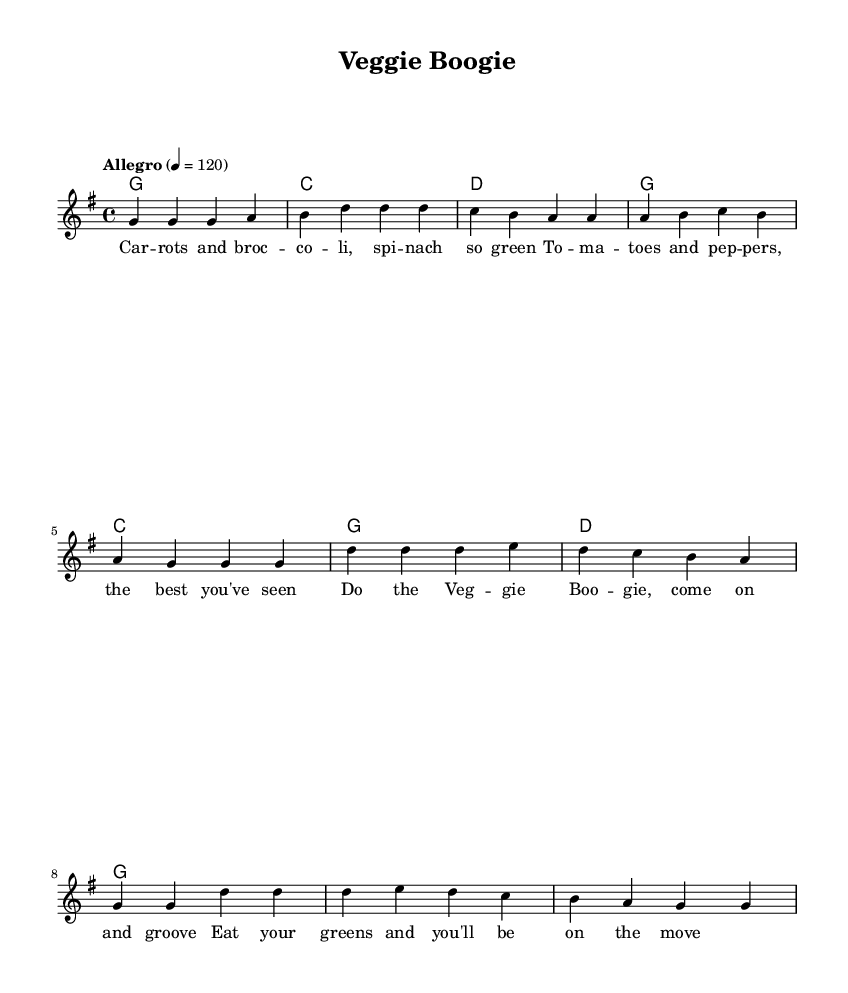What is the key signature of this music? The key signature is G major, which has one sharp (F#).
Answer: G major What is the time signature of this music? The time signature is 4/4, indicating four beats per measure.
Answer: 4/4 What is the tempo marking of this piece? The tempo marking is "Allegro," which typically means a fast tempo, around 120 beats per minute.
Answer: Allegro How many measures are in the verse section? The verse section has 5 measures, as counted from the melody line.
Answer: 5 What is the first chord of the chorus? The first chord of the chorus is C major, as indicated in the chord change section.
Answer: C Why is “Veggie Boogie” considered a Country Rock song? This piece includes upbeat rhythms and a danceable feel characteristic of Country Rock, combined with lyrical themes about healthy eating, which is common in the genre.
Answer: Upbeat rhythms, danceable feel Which vegetables are mentioned in the lyrics? The lyrics include carrots, broccoli, spinach, tomatoes, and peppers, highlighting various nutritious choices.
Answer: Carrots, broccoli, spinach, tomatoes, peppers 